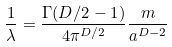<formula> <loc_0><loc_0><loc_500><loc_500>\frac { 1 } { \lambda } = \frac { \Gamma ( { D / 2 - 1 } ) } { 4 \pi ^ { D / 2 } } \frac { m } { a ^ { D - 2 } }</formula> 